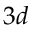<formula> <loc_0><loc_0><loc_500><loc_500>3 d</formula> 